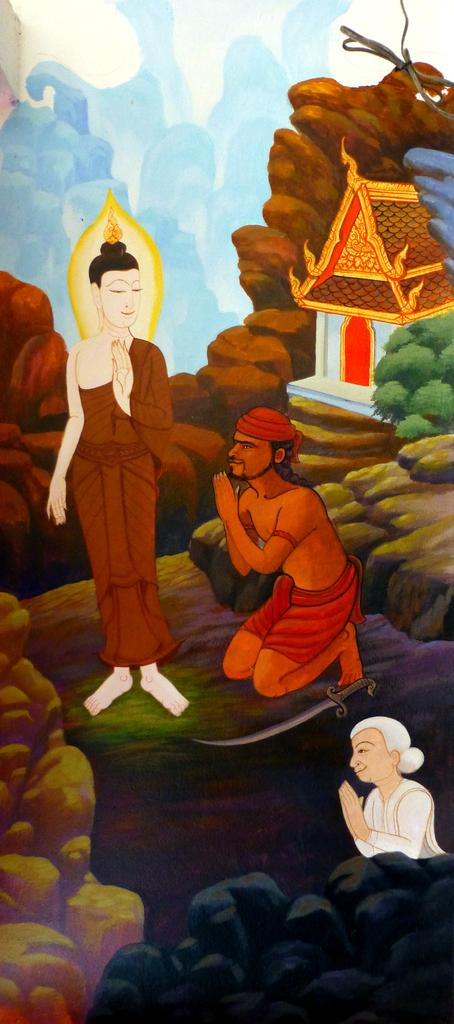What is the main subject of the image? The image contains a painting. What is depicted in the painting? The painting depicts three people wearing clothes. What other elements can be seen in the painting? There are stones, a house, and a tree in the image. How would you describe the weather in the image? The sky in the image is cloudy. What type of pizzas are being served at the event in the image? There is no event or pizzas present in the image; it features a painting with three people, stones, a house, a tree, and a cloudy sky. 